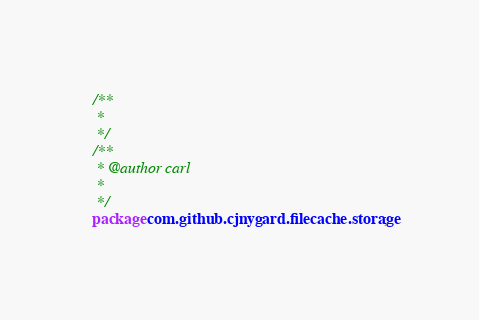Convert code to text. <code><loc_0><loc_0><loc_500><loc_500><_Java_>/**
 * 
 */
/**
 * @author carl
 *
 */
package com.github.cjnygard.filecache.storage;</code> 